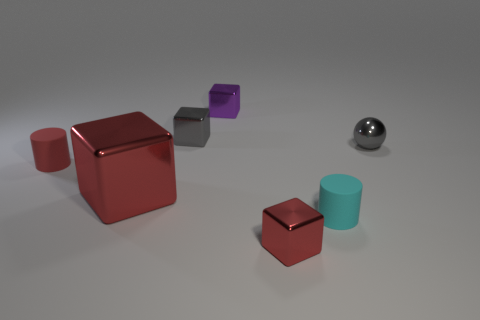What is the material of the small cyan thing that is the same shape as the red rubber object?
Your response must be concise. Rubber. The metallic sphere is what color?
Give a very brief answer. Gray. Does the small metallic sphere have the same color as the big shiny object?
Your answer should be very brief. No. How many metal things are purple objects or small red objects?
Provide a succinct answer. 2. There is a cylinder on the left side of the small red thing that is in front of the small red matte cylinder; is there a tiny gray cube that is left of it?
Keep it short and to the point. No. There is a red cylinder that is made of the same material as the cyan object; what size is it?
Your answer should be compact. Small. There is a tiny gray shiny sphere; are there any purple things on the right side of it?
Keep it short and to the point. No. There is a gray thing behind the tiny gray sphere; is there a tiny metallic ball to the left of it?
Keep it short and to the point. No. There is a rubber cylinder that is to the left of the tiny purple shiny cube; is its size the same as the gray thing left of the small sphere?
Your response must be concise. Yes. How many small things are either red shiny things or gray metal spheres?
Offer a very short reply. 2. 